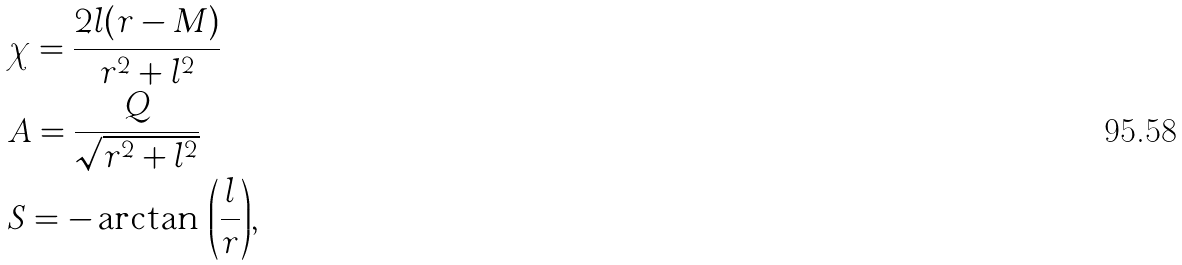<formula> <loc_0><loc_0><loc_500><loc_500>& \chi = \frac { 2 l ( r - M ) } { r ^ { 2 } + l ^ { 2 } } \\ & A = \frac { Q } { \sqrt { r ^ { 2 } + l ^ { 2 } } } \\ & S = - \arctan { \, \left ( \frac { l } { r } \right ) } ,</formula> 